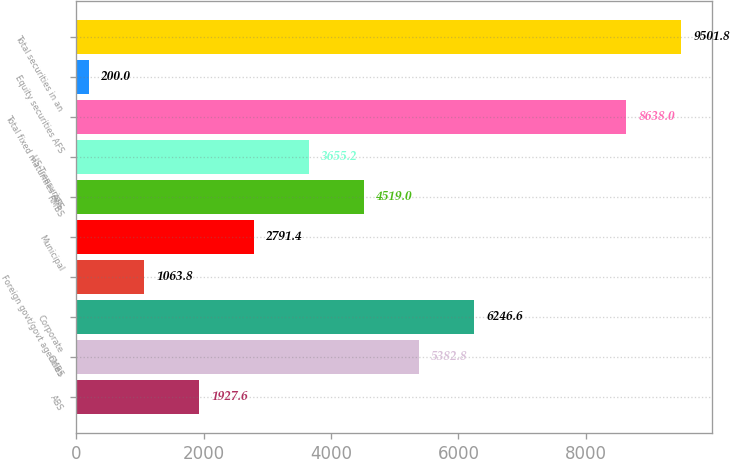Convert chart. <chart><loc_0><loc_0><loc_500><loc_500><bar_chart><fcel>ABS<fcel>CMBS<fcel>Corporate<fcel>Foreign govt/govt agencies<fcel>Municipal<fcel>RMBS<fcel>US Treasuries<fcel>Total fixed maturities AFS<fcel>Equity securities AFS<fcel>Total securities in an<nl><fcel>1927.6<fcel>5382.8<fcel>6246.6<fcel>1063.8<fcel>2791.4<fcel>4519<fcel>3655.2<fcel>8638<fcel>200<fcel>9501.8<nl></chart> 